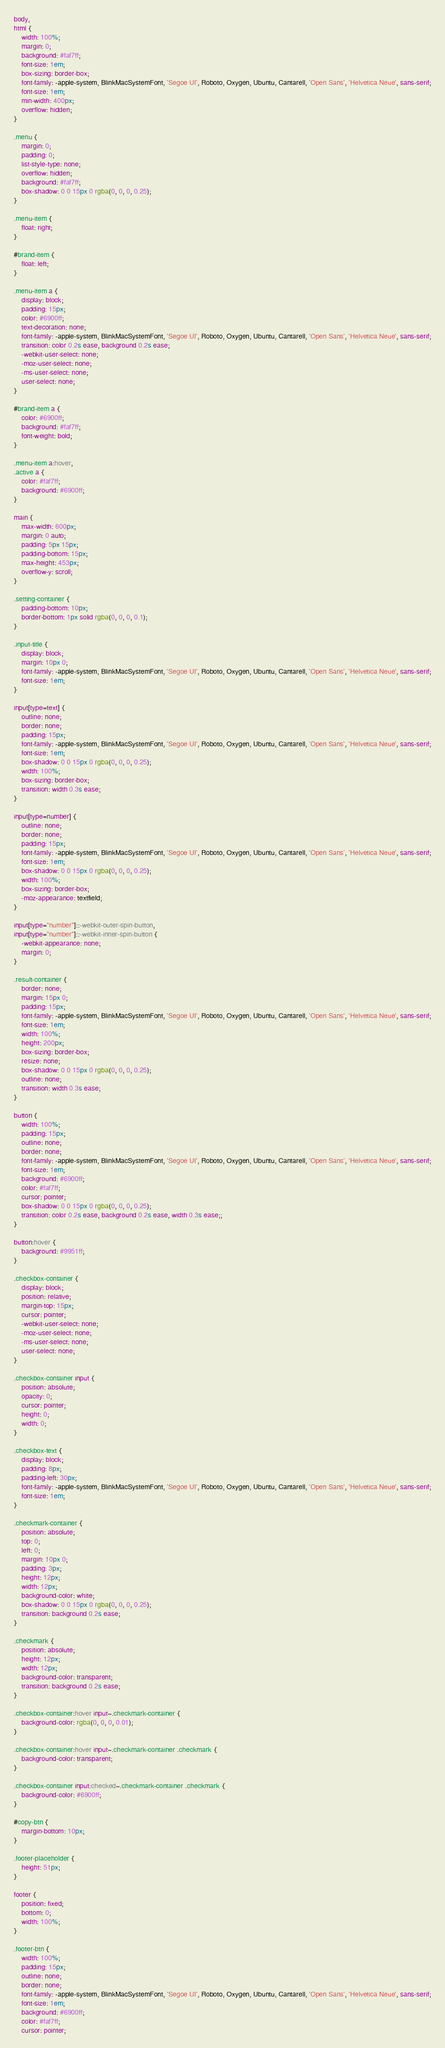Convert code to text. <code><loc_0><loc_0><loc_500><loc_500><_CSS_>body,
html {
    width: 100%;
    margin: 0;
    background: #faf7ff;
    font-size: 1em;
    box-sizing: border-box;
    font-family: -apple-system, BlinkMacSystemFont, 'Segoe UI', Roboto, Oxygen, Ubuntu, Cantarell, 'Open Sans', 'Helvetica Neue', sans-serif;
    font-size: 1em;
    min-width: 400px;
    overflow: hidden;
}

.menu {
    margin: 0;
    padding: 0;
    list-style-type: none;
    overflow: hidden;
    background: #faf7ff;
    box-shadow: 0 0 15px 0 rgba(0, 0, 0, 0.25);
}

.menu-item {
    float: right;
}

#brand-item {
    float: left;
}

.menu-item a {
    display: block;
    padding: 15px;
    color: #6900ff;
    text-decoration: none;
    font-family: -apple-system, BlinkMacSystemFont, 'Segoe UI', Roboto, Oxygen, Ubuntu, Cantarell, 'Open Sans', 'Helvetica Neue', sans-serif;
    transition: color 0.2s ease, background 0.2s ease;
    -webkit-user-select: none;
    -moz-user-select: none;
    -ms-user-select: none;
    user-select: none;
}

#brand-item a {
    color: #6900ff;
    background: #faf7ff;
    font-weight: bold;
}

.menu-item a:hover,
.active a {
    color: #faf7ff;
    background: #6900ff;
}

main {
    max-width: 600px;
    margin: 0 auto;
    padding: 5px 15px;
    padding-bottom: 15px;
    max-height: 453px;
    overflow-y: scroll;
}

.setting-container {
    padding-bottom: 10px;
    border-bottom: 1px solid rgba(0, 0, 0, 0.1);
}

.input-title {
    display: block;
    margin: 10px 0;
    font-family: -apple-system, BlinkMacSystemFont, 'Segoe UI', Roboto, Oxygen, Ubuntu, Cantarell, 'Open Sans', 'Helvetica Neue', sans-serif;
    font-size: 1em;
}

input[type=text] {
    outline: none;
    border: none;
    padding: 15px;
    font-family: -apple-system, BlinkMacSystemFont, 'Segoe UI', Roboto, Oxygen, Ubuntu, Cantarell, 'Open Sans', 'Helvetica Neue', sans-serif;
    font-size: 1em;
    box-shadow: 0 0 15px 0 rgba(0, 0, 0, 0.25);
    width: 100%;
    box-sizing: border-box;
    transition: width 0.3s ease;
}

input[type=number] {
    outline: none;
    border: none;
    padding: 15px;
    font-family: -apple-system, BlinkMacSystemFont, 'Segoe UI', Roboto, Oxygen, Ubuntu, Cantarell, 'Open Sans', 'Helvetica Neue', sans-serif;
    font-size: 1em;
    box-shadow: 0 0 15px 0 rgba(0, 0, 0, 0.25);
    width: 100%;
    box-sizing: border-box;
    -moz-appearance: textfield;
}

input[type="number"]::-webkit-outer-spin-button,
input[type="number"]::-webkit-inner-spin-button {
    -webkit-appearance: none;
    margin: 0;
}

.result-container {
    border: none;
    margin: 15px 0;
    padding: 15px;
    font-family: -apple-system, BlinkMacSystemFont, 'Segoe UI', Roboto, Oxygen, Ubuntu, Cantarell, 'Open Sans', 'Helvetica Neue', sans-serif;
    font-size: 1em;
    width: 100%;
    height: 200px;
    box-sizing: border-box;
    resize: none;
    box-shadow: 0 0 15px 0 rgba(0, 0, 0, 0.25);
    outline: none;
    transition: width 0.3s ease;
}

button {
    width: 100%;
    padding: 15px;
    outline: none;
    border: none;
    font-family: -apple-system, BlinkMacSystemFont, 'Segoe UI', Roboto, Oxygen, Ubuntu, Cantarell, 'Open Sans', 'Helvetica Neue', sans-serif;
    font-size: 1em;
    background: #6900ff;
    color: #faf7ff;
    cursor: pointer;
    box-shadow: 0 0 15px 0 rgba(0, 0, 0, 0.25);
    transition: color 0.2s ease, background 0.2s ease, width 0.3s ease;;
}

button:hover {
    background: #9951ff;
}

.checkbox-container {
    display: block;
    position: relative;
    margin-top: 15px;
    cursor: pointer;
    -webkit-user-select: none;
    -moz-user-select: none;
    -ms-user-select: none;
    user-select: none;
}

.checkbox-container input {
    position: absolute;
    opacity: 0;
    cursor: pointer;
    height: 0;
    width: 0;
}

.checkbox-text {
    display: block;
    padding: 8px;
    padding-left: 30px;
    font-family: -apple-system, BlinkMacSystemFont, 'Segoe UI', Roboto, Oxygen, Ubuntu, Cantarell, 'Open Sans', 'Helvetica Neue', sans-serif;
    font-size: 1em;
}

.checkmark-container {
    position: absolute;
    top: 0;
    left: 0;
    margin: 10px 0;
    padding: 3px;
    height: 12px;
    width: 12px;
    background-color: white;
    box-shadow: 0 0 15px 0 rgba(0, 0, 0, 0.25);
    transition: background 0.2s ease;
}

.checkmark {
    position: absolute;
    height: 12px;
    width: 12px;
    background-color: transparent;
    transition: background 0.2s ease;
}

.checkbox-container:hover input~.checkmark-container {
    background-color: rgba(0, 0, 0, 0.01);
}

.checkbox-container:hover input~.checkmark-container .checkmark {
    background-color: transparent;
}

.checkbox-container input:checked~.checkmark-container .checkmark {
    background-color: #6900ff;
}

#copy-btn {
    margin-bottom: 10px;
}

.footer-placeholder {
    height: 51px;
}

footer {
    position: fixed;
    bottom: 0;
    width: 100%;
}

.footer-btn {
    width: 100%;
    padding: 15px;
    outline: none;
    border: none;
    font-family: -apple-system, BlinkMacSystemFont, 'Segoe UI', Roboto, Oxygen, Ubuntu, Cantarell, 'Open Sans', 'Helvetica Neue', sans-serif;
    font-size: 1em;
    background: #6900ff;
    color: #faf7ff;
    cursor: pointer;</code> 